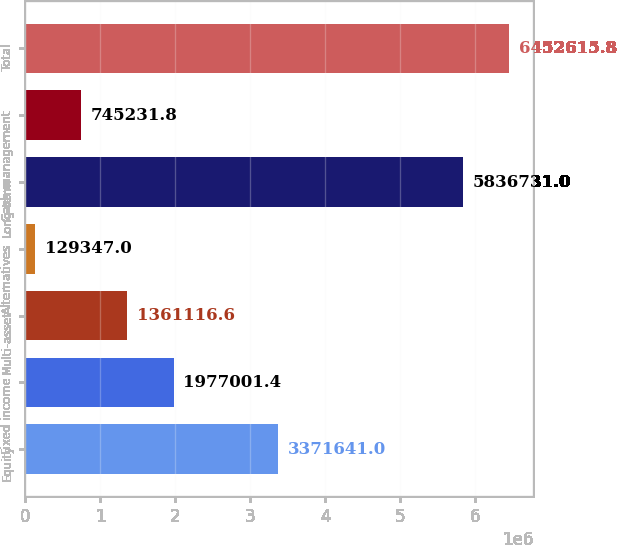Convert chart to OTSL. <chart><loc_0><loc_0><loc_500><loc_500><bar_chart><fcel>Equity<fcel>Fixed income<fcel>Multi-asset<fcel>Alternatives<fcel>Long-term<fcel>Cash management<fcel>Total<nl><fcel>3.37164e+06<fcel>1.977e+06<fcel>1.36112e+06<fcel>129347<fcel>5.83673e+06<fcel>745232<fcel>6.45262e+06<nl></chart> 